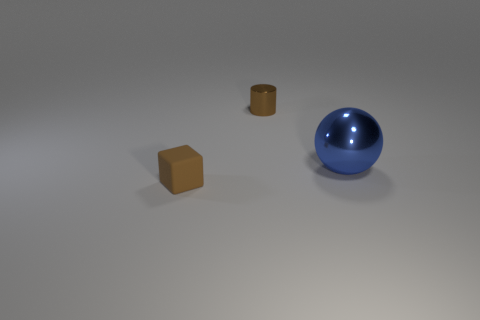Is there any other thing that has the same size as the brown matte cube?
Your answer should be very brief. Yes. Are there any small things of the same color as the small metallic cylinder?
Your answer should be very brief. Yes. What is the size of the blue thing that is made of the same material as the brown cylinder?
Your answer should be very brief. Large. There is a brown object that is in front of the metal thing on the right side of the thing behind the large ball; what shape is it?
Keep it short and to the point. Cube. There is a object that is both behind the matte block and on the left side of the large blue metallic sphere; how big is it?
Give a very brief answer. Small. There is a metal thing that is the same color as the cube; what is its shape?
Ensure brevity in your answer.  Cylinder. What is the color of the shiny sphere?
Offer a very short reply. Blue. How big is the sphere that is behind the small matte block?
Make the answer very short. Large. There is a blue metallic sphere that is on the right side of the tiny brown thing that is on the left side of the cylinder; how many brown cylinders are on the left side of it?
Offer a very short reply. 1. What color is the metal ball that is behind the tiny brown thing in front of the tiny metal cylinder?
Keep it short and to the point. Blue. 